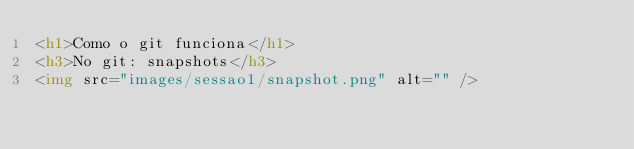Convert code to text. <code><loc_0><loc_0><loc_500><loc_500><_HTML_><h1>Como o git funciona</h1>
<h3>No git: snapshots</h3>
<img src="images/sessao1/snapshot.png" alt="" />
</code> 